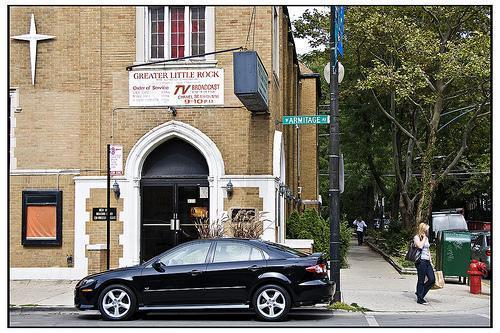How many people are in the image?
Give a very brief answer. 2. 